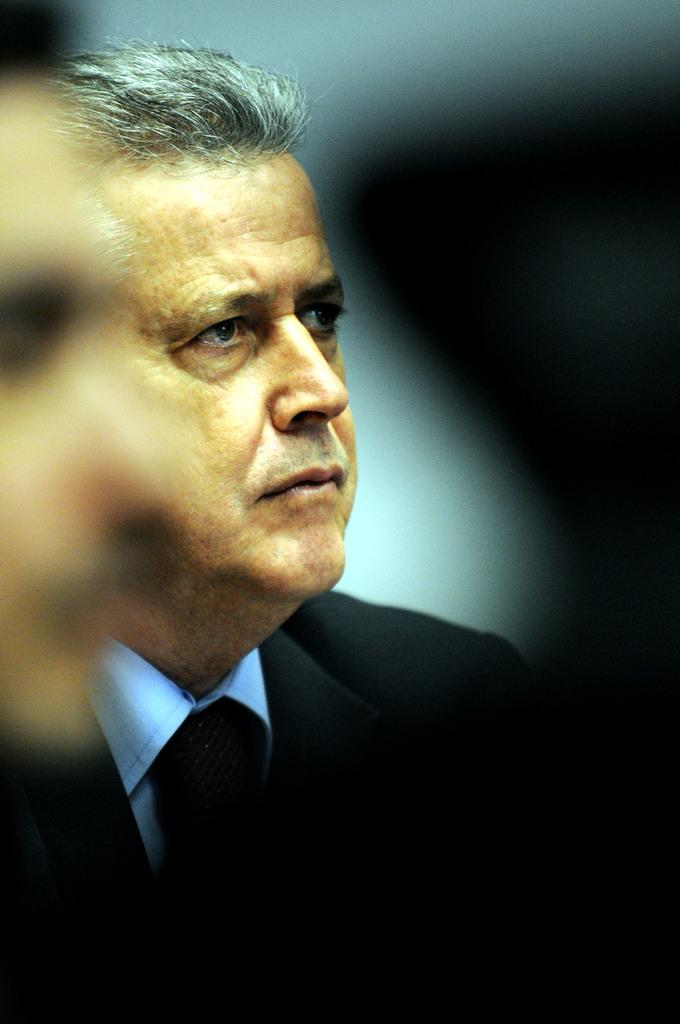Who is present on the right side of the image? There is a man on the right side of the image. What does the man start doing in the image? There is no indication of the man starting any action in the image. How does the man show respect in the image? There is no indication of the man showing respect in the image. 